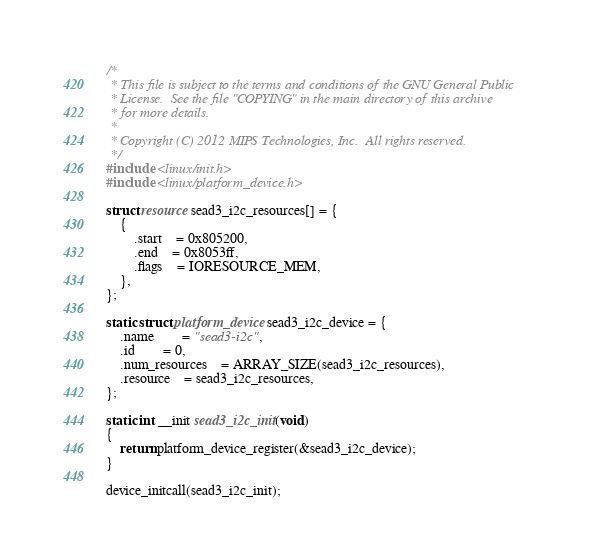<code> <loc_0><loc_0><loc_500><loc_500><_C_>/*
 * This file is subject to the terms and conditions of the GNU General Public
 * License.  See the file "COPYING" in the main directory of this archive
 * for more details.
 *
 * Copyright (C) 2012 MIPS Technologies, Inc.  All rights reserved.
 */
#include <linux/init.h>
#include <linux/platform_device.h>

struct resource sead3_i2c_resources[] = {
	{
		.start	= 0x805200,
		.end	= 0x8053ff,
		.flags	= IORESOURCE_MEM,
	},
};

static struct platform_device sead3_i2c_device = {
	.name		= "sead3-i2c",
	.id		= 0,
	.num_resources	= ARRAY_SIZE(sead3_i2c_resources),
	.resource	= sead3_i2c_resources,
};

static int __init sead3_i2c_init(void)
{
	return platform_device_register(&sead3_i2c_device);
}

device_initcall(sead3_i2c_init);
</code> 